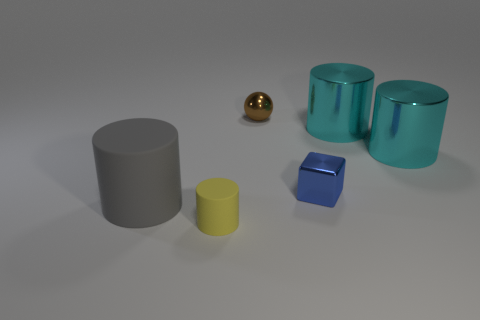How many other objects are there of the same material as the tiny ball?
Ensure brevity in your answer.  3. There is a matte thing that is on the left side of the yellow thing; how many rubber things are in front of it?
Offer a very short reply. 1. Is there any other thing that has the same shape as the yellow matte object?
Offer a very short reply. Yes. Do the object that is in front of the gray cylinder and the big object on the left side of the small brown sphere have the same color?
Provide a short and direct response. No. Are there fewer tiny rubber things than cylinders?
Offer a very short reply. Yes. What is the shape of the tiny object that is to the right of the tiny shiny thing behind the tiny blue cube?
Offer a terse response. Cube. Is there any other thing that is the same size as the blue metal thing?
Ensure brevity in your answer.  Yes. There is a rubber object that is in front of the gray rubber thing that is on the left side of the small metal thing that is behind the tiny blue metal block; what is its shape?
Your answer should be compact. Cylinder. How many objects are big cylinders that are behind the gray object or big cylinders that are behind the gray cylinder?
Make the answer very short. 2. Is the size of the gray rubber cylinder the same as the shiny object that is left of the blue metal thing?
Provide a succinct answer. No. 